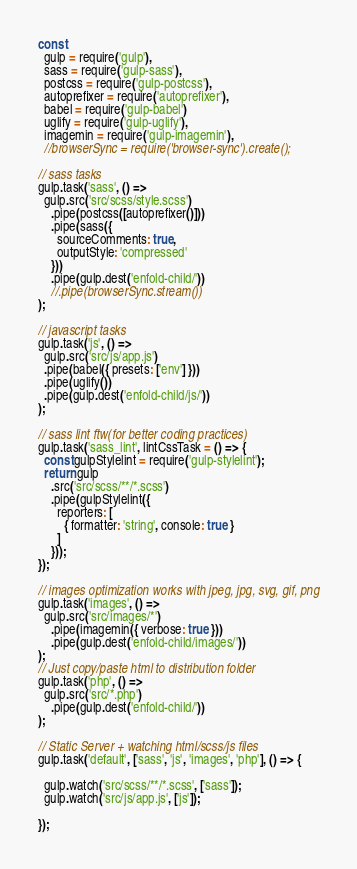<code> <loc_0><loc_0><loc_500><loc_500><_JavaScript_>const
  gulp = require('gulp'),
  sass = require('gulp-sass'),
  postcss = require('gulp-postcss'),
  autoprefixer = require('autoprefixer'),
  babel = require('gulp-babel')
  uglify = require('gulp-uglify'),
  imagemin = require('gulp-imagemin'),
  //browserSync = require('browser-sync').create();

// sass tasks
gulp.task('sass', () =>
  gulp.src('src/scss/style.scss')
    .pipe(postcss([autoprefixer()]))
    .pipe(sass({
      sourceComments: true,
      outputStyle: 'compressed'
    }))
    .pipe(gulp.dest('enfold-child/'))
    //.pipe(browserSync.stream())
);   

// javascript tasks
gulp.task('js', () =>
  gulp.src('src/js/app.js')
  .pipe(babel({ presets: ['env'] }))
  .pipe(uglify())
  .pipe(gulp.dest('enfold-child/js/'))
);

// sass lint ftw(for better coding practices)
gulp.task('sass_lint', lintCssTask = () => {
  const gulpStylelint = require('gulp-stylelint');
  return gulp
    .src('src/scss/**/*.scss')
    .pipe(gulpStylelint({
      reporters: [
        { formatter: 'string', console: true }
      ]
    }));
});

// images optimization works with jpeg, jpg, svg, gif, png
gulp.task('images', () =>
  gulp.src('src/images/*')
    .pipe(imagemin({ verbose: true }))
    .pipe(gulp.dest('enfold-child/images/'))
);
// Just copy/paste html to distribution folder
gulp.task('php', () =>
  gulp.src('src/*.php')
    .pipe(gulp.dest('enfold-child/'))
);

// Static Server + watching html/scss/js files
gulp.task('default', ['sass', 'js', 'images', 'php'], () => {

  gulp.watch('src/scss/**/*.scss', ['sass']);
  gulp.watch('src/js/app.js', ['js']);

});
</code> 